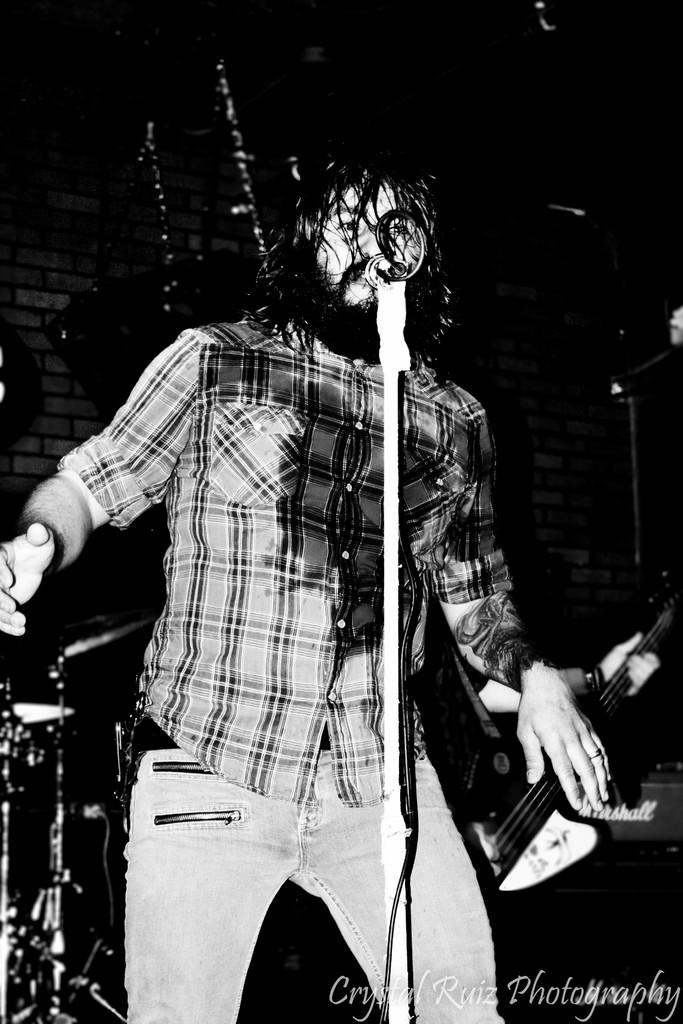What is the man in the image doing? The man is singing in the image. What object is the man using while singing? There is a microphone in the image. What can be seen in the background of the image? There are musical instruments in the background. What specific musical instrument is visible in the image? There is a guitar in the image in the image. How many icicles are hanging from the guitar in the image? There are no icicles present in the image, as it is not a cold environment where icicles would form. 